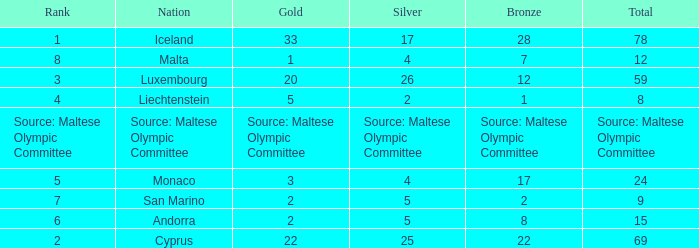How many bronze medals does the nation ranked number 1 have? 28.0. 